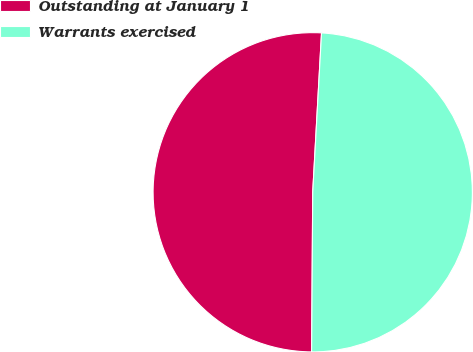Convert chart to OTSL. <chart><loc_0><loc_0><loc_500><loc_500><pie_chart><fcel>Outstanding at January 1<fcel>Warrants exercised<nl><fcel>50.77%<fcel>49.23%<nl></chart> 